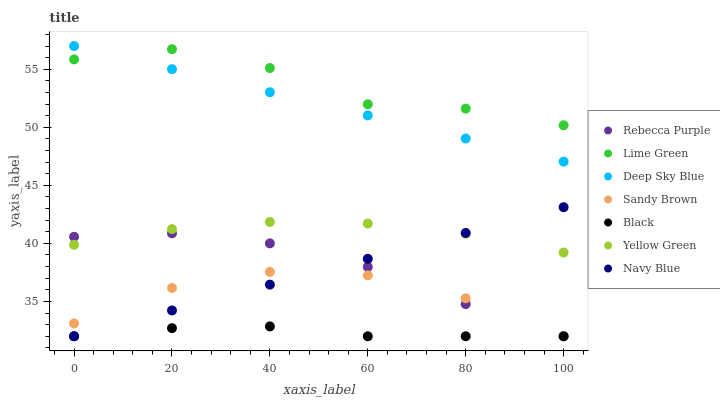Does Black have the minimum area under the curve?
Answer yes or no. Yes. Does Lime Green have the maximum area under the curve?
Answer yes or no. Yes. Does Lime Green have the minimum area under the curve?
Answer yes or no. No. Does Black have the maximum area under the curve?
Answer yes or no. No. Is Deep Sky Blue the smoothest?
Answer yes or no. Yes. Is Lime Green the roughest?
Answer yes or no. Yes. Is Black the smoothest?
Answer yes or no. No. Is Black the roughest?
Answer yes or no. No. Does Black have the lowest value?
Answer yes or no. Yes. Does Lime Green have the lowest value?
Answer yes or no. No. Does Deep Sky Blue have the highest value?
Answer yes or no. Yes. Does Lime Green have the highest value?
Answer yes or no. No. Is Navy Blue less than Deep Sky Blue?
Answer yes or no. Yes. Is Yellow Green greater than Black?
Answer yes or no. Yes. Does Black intersect Rebecca Purple?
Answer yes or no. Yes. Is Black less than Rebecca Purple?
Answer yes or no. No. Is Black greater than Rebecca Purple?
Answer yes or no. No. Does Navy Blue intersect Deep Sky Blue?
Answer yes or no. No. 